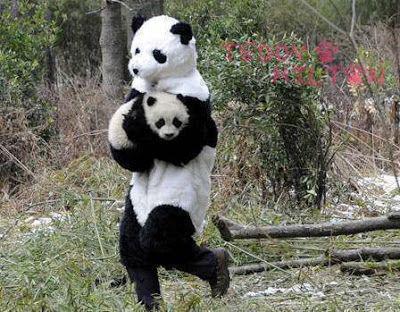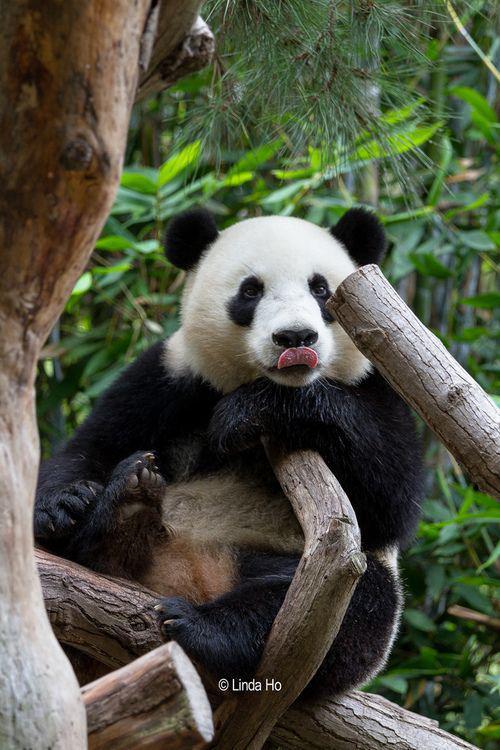The first image is the image on the left, the second image is the image on the right. Assess this claim about the two images: "Some pandas are in the snow.". Correct or not? Answer yes or no. No. The first image is the image on the left, the second image is the image on the right. Given the left and right images, does the statement "There is at least one image where a single bear is animal is sitting alone." hold true? Answer yes or no. Yes. 